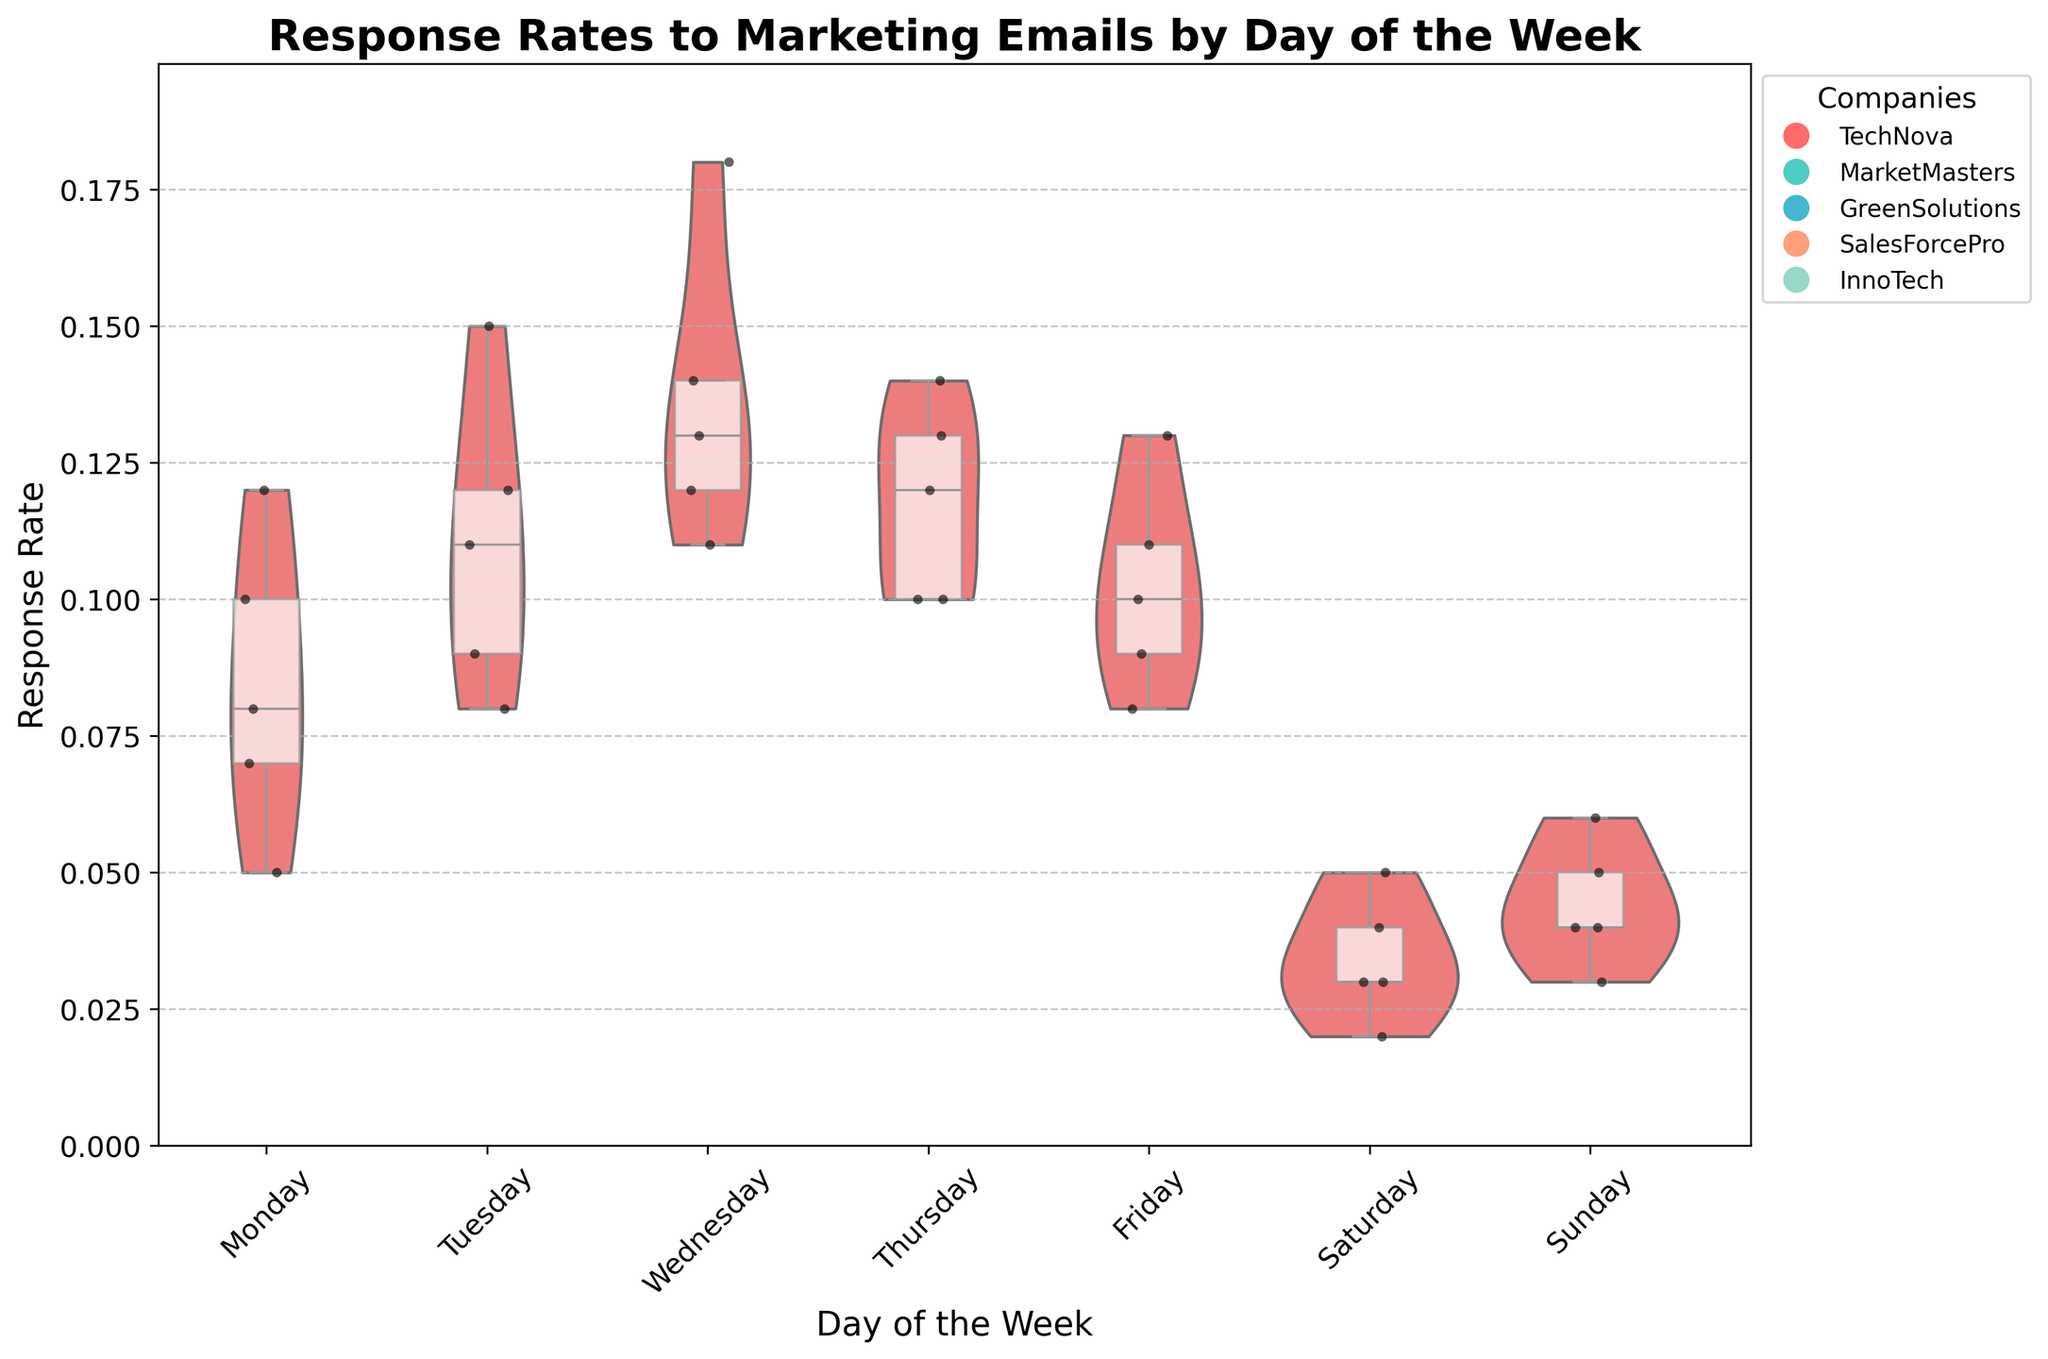what is the title of the plot? The title of the plot is located at the top of the figure, and it usually summarizes the main purpose or the content of the chart. Here, the title states "Response Rates to Marketing Emails by Day of the Week".
Answer: Response Rates to Marketing Emails by Day of the Week what is represented on the y-axis? The y-axis displays the variable that the plot is measuring. In this case, the y-axis is labeled "Response Rate" and represents the response rates to marketing emails.
Answer: Response Rate on which day do marketing emails receive the highest median response rate? The box plot overlay provides the median value of each day's responses. By observing the box plots, Wednesday's box plot exhibits the highest median value.
Answer: Wednesday how many companies are included in the analysis? The legend on the right side of the figure indicates the number of different markers, each representing a different company. By counting these markers, we determine that there are five companies included.
Answer: five what is the maximum response rate observed in the data? The maximum response rate can be identified by looking at the highest point on the y-axis scale or the tip of the violin plots, which represents the highest response rate observed. The maximum response rate is 0.18.
Answer: 0.18 which day has the lowest spread of response rates? The spread of response rates for each day can be visualized by the width of the violins. A narrower violin indicates a smaller range of data. Saturday shows the narrowest violin, indicating the lowest spread of response rates.
Answer: Saturday compare the median response rates of Monday and Thursday. which day has a higher median? The box plot's median line on Monday and Thursday allows us to compare. The median line for Monday is slightly lower than Thursday’s, indicating that Thursday has a higher median response rate.
Answer: Thursday how do the interquartile ranges (IQR) of Tuesday and Friday compare? The IQR is represented by the height of the box in the box plot. By comparing the heights of the boxes for Tuesday and Friday, we see that Tuesday has a larger IQR compared to Friday.
Answer: Tuesday has a larger IQR which days exhibit response rates lower than 0.05? By observing the position of data points below 0.05 on the y-axis, Saturday and Sunday both show data points below this value.
Answer: Saturday and Sunday outline the response rate trend from Saturday through Wednesday. Following the position of the violin plots from Saturday through Wednesday, we observe an increasing trend in response rates. Saturdays have the lowest, and rates progressively increase through Sunday, Monday, Tuesday, and reach a peak on Wednesday.
Answer: Increasing trend from Saturday to Wednesday 